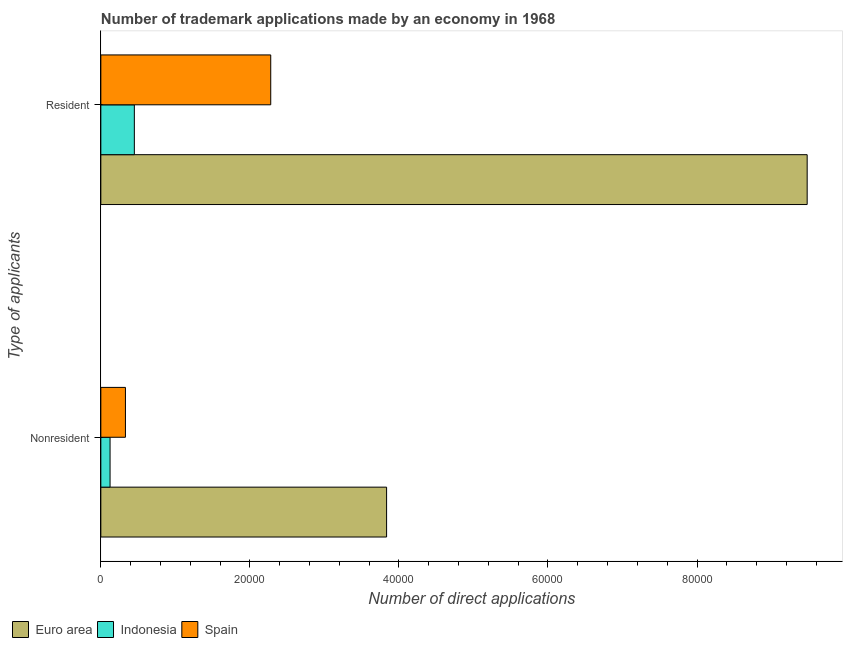Are the number of bars on each tick of the Y-axis equal?
Your response must be concise. Yes. How many bars are there on the 2nd tick from the top?
Your answer should be very brief. 3. What is the label of the 2nd group of bars from the top?
Ensure brevity in your answer.  Nonresident. What is the number of trademark applications made by residents in Spain?
Your response must be concise. 2.28e+04. Across all countries, what is the maximum number of trademark applications made by residents?
Offer a terse response. 9.48e+04. Across all countries, what is the minimum number of trademark applications made by non residents?
Give a very brief answer. 1238. What is the total number of trademark applications made by non residents in the graph?
Keep it short and to the point. 4.29e+04. What is the difference between the number of trademark applications made by non residents in Indonesia and that in Spain?
Offer a very short reply. -2062. What is the difference between the number of trademark applications made by residents in Indonesia and the number of trademark applications made by non residents in Euro area?
Keep it short and to the point. -3.38e+04. What is the average number of trademark applications made by non residents per country?
Ensure brevity in your answer.  1.43e+04. What is the difference between the number of trademark applications made by non residents and number of trademark applications made by residents in Euro area?
Your answer should be very brief. -5.64e+04. What is the ratio of the number of trademark applications made by residents in Indonesia to that in Spain?
Your response must be concise. 0.2. In how many countries, is the number of trademark applications made by residents greater than the average number of trademark applications made by residents taken over all countries?
Offer a very short reply. 1. What does the 1st bar from the top in Nonresident represents?
Your answer should be very brief. Spain. What does the 2nd bar from the bottom in Nonresident represents?
Your answer should be very brief. Indonesia. How many bars are there?
Your answer should be very brief. 6. How many countries are there in the graph?
Provide a short and direct response. 3. What is the difference between two consecutive major ticks on the X-axis?
Your response must be concise. 2.00e+04. Are the values on the major ticks of X-axis written in scientific E-notation?
Make the answer very short. No. Does the graph contain grids?
Your response must be concise. No. Where does the legend appear in the graph?
Your response must be concise. Bottom left. How are the legend labels stacked?
Make the answer very short. Horizontal. What is the title of the graph?
Your answer should be very brief. Number of trademark applications made by an economy in 1968. Does "New Caledonia" appear as one of the legend labels in the graph?
Make the answer very short. No. What is the label or title of the X-axis?
Keep it short and to the point. Number of direct applications. What is the label or title of the Y-axis?
Your answer should be very brief. Type of applicants. What is the Number of direct applications of Euro area in Nonresident?
Your response must be concise. 3.83e+04. What is the Number of direct applications of Indonesia in Nonresident?
Offer a very short reply. 1238. What is the Number of direct applications of Spain in Nonresident?
Offer a very short reply. 3300. What is the Number of direct applications in Euro area in Resident?
Your answer should be very brief. 9.48e+04. What is the Number of direct applications in Indonesia in Resident?
Your answer should be very brief. 4496. What is the Number of direct applications of Spain in Resident?
Ensure brevity in your answer.  2.28e+04. Across all Type of applicants, what is the maximum Number of direct applications of Euro area?
Provide a short and direct response. 9.48e+04. Across all Type of applicants, what is the maximum Number of direct applications of Indonesia?
Keep it short and to the point. 4496. Across all Type of applicants, what is the maximum Number of direct applications in Spain?
Your answer should be compact. 2.28e+04. Across all Type of applicants, what is the minimum Number of direct applications of Euro area?
Your answer should be compact. 3.83e+04. Across all Type of applicants, what is the minimum Number of direct applications in Indonesia?
Your response must be concise. 1238. Across all Type of applicants, what is the minimum Number of direct applications in Spain?
Your answer should be compact. 3300. What is the total Number of direct applications of Euro area in the graph?
Your response must be concise. 1.33e+05. What is the total Number of direct applications in Indonesia in the graph?
Provide a succinct answer. 5734. What is the total Number of direct applications in Spain in the graph?
Offer a terse response. 2.61e+04. What is the difference between the Number of direct applications of Euro area in Nonresident and that in Resident?
Offer a terse response. -5.64e+04. What is the difference between the Number of direct applications in Indonesia in Nonresident and that in Resident?
Make the answer very short. -3258. What is the difference between the Number of direct applications in Spain in Nonresident and that in Resident?
Ensure brevity in your answer.  -1.95e+04. What is the difference between the Number of direct applications in Euro area in Nonresident and the Number of direct applications in Indonesia in Resident?
Give a very brief answer. 3.38e+04. What is the difference between the Number of direct applications in Euro area in Nonresident and the Number of direct applications in Spain in Resident?
Offer a very short reply. 1.55e+04. What is the difference between the Number of direct applications in Indonesia in Nonresident and the Number of direct applications in Spain in Resident?
Offer a terse response. -2.16e+04. What is the average Number of direct applications of Euro area per Type of applicants?
Your answer should be compact. 6.66e+04. What is the average Number of direct applications in Indonesia per Type of applicants?
Your answer should be very brief. 2867. What is the average Number of direct applications of Spain per Type of applicants?
Keep it short and to the point. 1.30e+04. What is the difference between the Number of direct applications of Euro area and Number of direct applications of Indonesia in Nonresident?
Make the answer very short. 3.71e+04. What is the difference between the Number of direct applications of Euro area and Number of direct applications of Spain in Nonresident?
Ensure brevity in your answer.  3.50e+04. What is the difference between the Number of direct applications in Indonesia and Number of direct applications in Spain in Nonresident?
Give a very brief answer. -2062. What is the difference between the Number of direct applications of Euro area and Number of direct applications of Indonesia in Resident?
Offer a terse response. 9.03e+04. What is the difference between the Number of direct applications of Euro area and Number of direct applications of Spain in Resident?
Your answer should be compact. 7.20e+04. What is the difference between the Number of direct applications of Indonesia and Number of direct applications of Spain in Resident?
Give a very brief answer. -1.83e+04. What is the ratio of the Number of direct applications of Euro area in Nonresident to that in Resident?
Offer a terse response. 0.4. What is the ratio of the Number of direct applications of Indonesia in Nonresident to that in Resident?
Offer a terse response. 0.28. What is the ratio of the Number of direct applications in Spain in Nonresident to that in Resident?
Your response must be concise. 0.14. What is the difference between the highest and the second highest Number of direct applications of Euro area?
Your answer should be very brief. 5.64e+04. What is the difference between the highest and the second highest Number of direct applications of Indonesia?
Ensure brevity in your answer.  3258. What is the difference between the highest and the second highest Number of direct applications of Spain?
Your answer should be compact. 1.95e+04. What is the difference between the highest and the lowest Number of direct applications in Euro area?
Your response must be concise. 5.64e+04. What is the difference between the highest and the lowest Number of direct applications of Indonesia?
Your answer should be compact. 3258. What is the difference between the highest and the lowest Number of direct applications of Spain?
Offer a terse response. 1.95e+04. 